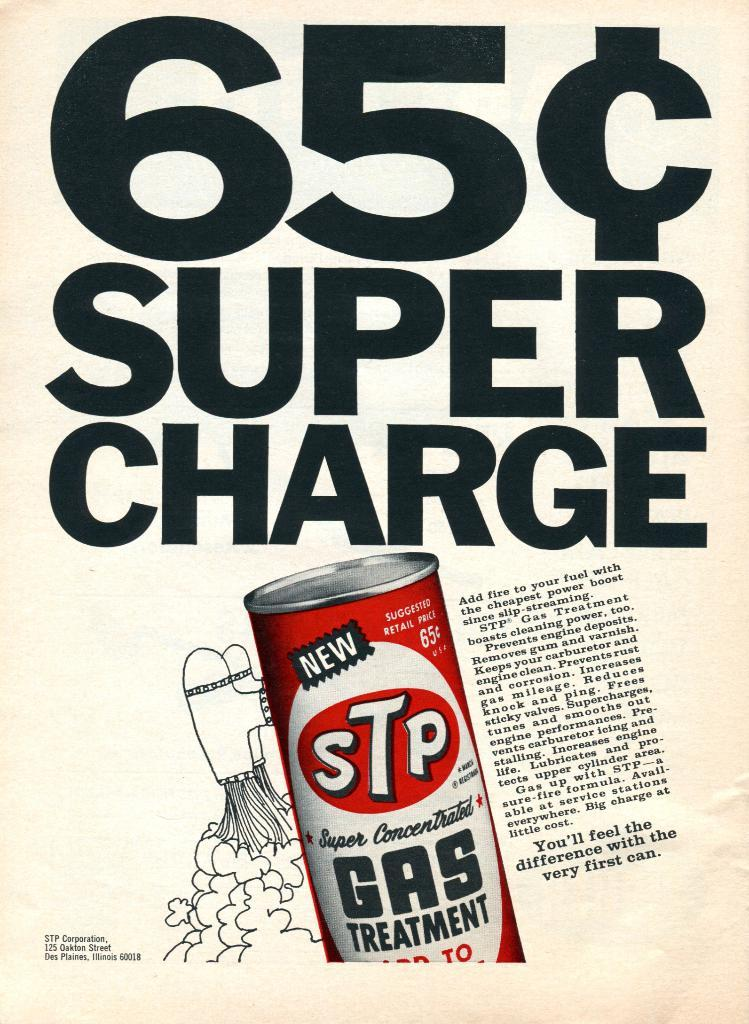<image>
Share a concise interpretation of the image provided. An advertisement displaying a 65 cent super charge 